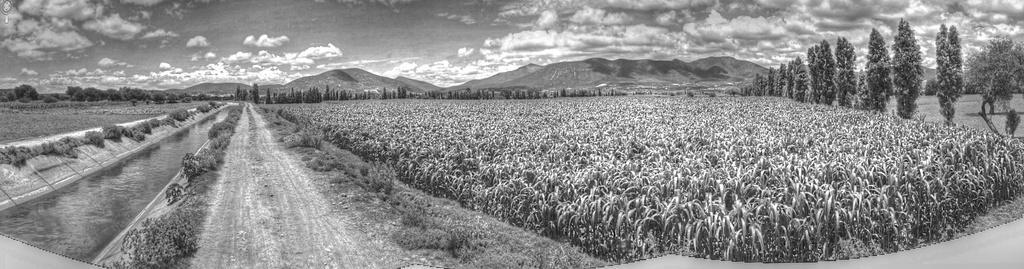Can you describe this image briefly? This picture might be taken from outside of the city. In this image, on the right side, we can see some trees. On the left side, we can see some plants and water in a lake. In the middle of the image, we can see some plants. In the background, we can see some trees, rocks. At the top, we can see a sky, at the bottom there is a land with some stones. 